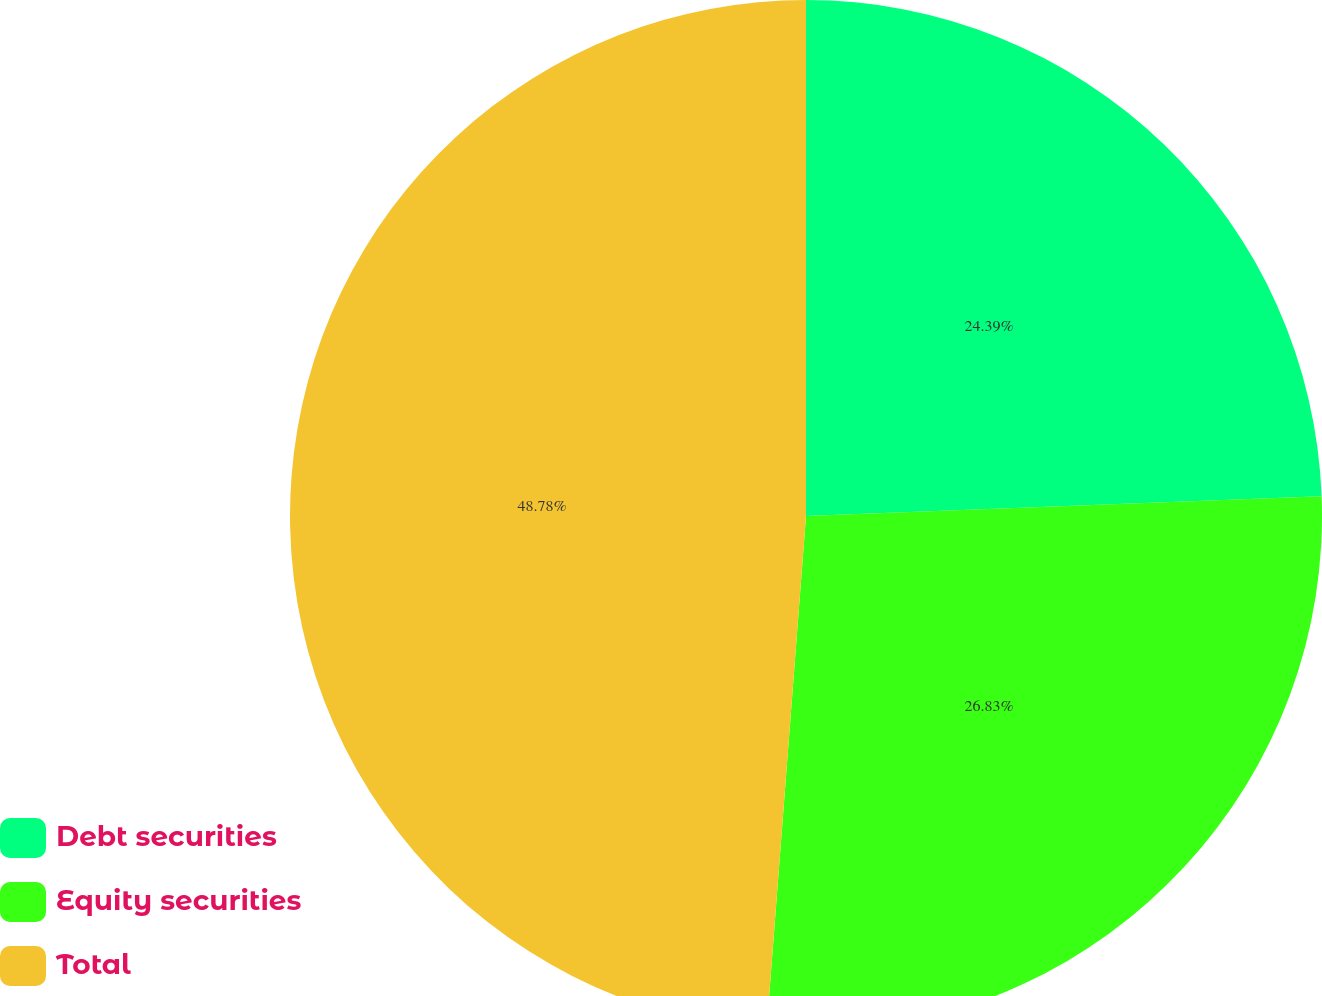<chart> <loc_0><loc_0><loc_500><loc_500><pie_chart><fcel>Debt securities<fcel>Equity securities<fcel>Total<nl><fcel>24.39%<fcel>26.83%<fcel>48.78%<nl></chart> 